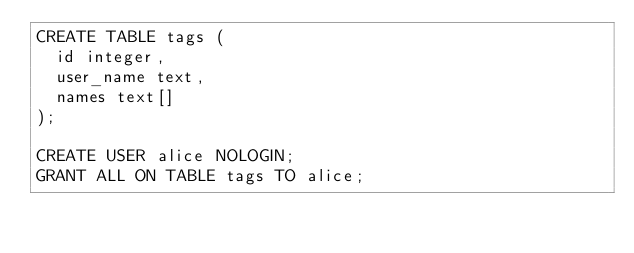<code> <loc_0><loc_0><loc_500><loc_500><_SQL_>CREATE TABLE tags (
  id integer,
  user_name text,
  names text[]
);

CREATE USER alice NOLOGIN;
GRANT ALL ON TABLE tags TO alice;
</code> 